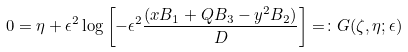Convert formula to latex. <formula><loc_0><loc_0><loc_500><loc_500>0 = \eta + \epsilon ^ { 2 } \log \left [ - \epsilon ^ { 2 } \frac { ( x B _ { 1 } + Q B _ { 3 } - y ^ { 2 } B _ { 2 } ) } { D } \right ] = \colon G ( \zeta , \eta ; \epsilon )</formula> 